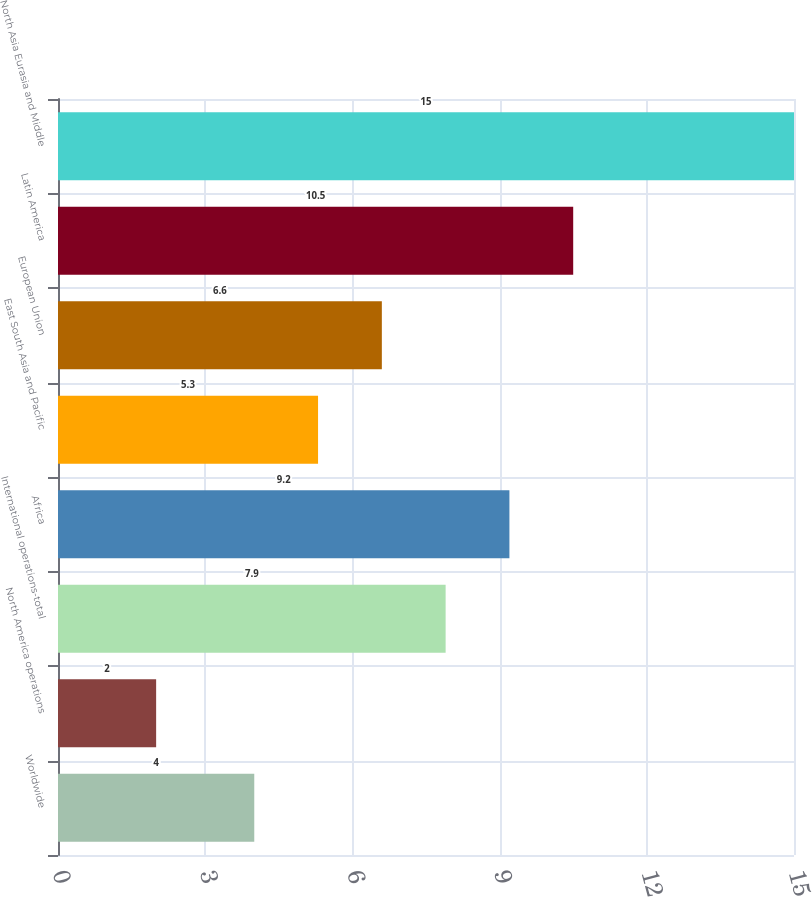Convert chart. <chart><loc_0><loc_0><loc_500><loc_500><bar_chart><fcel>Worldwide<fcel>North America operations<fcel>International operations-total<fcel>Africa<fcel>East South Asia and Pacific<fcel>European Union<fcel>Latin America<fcel>North Asia Eurasia and Middle<nl><fcel>4<fcel>2<fcel>7.9<fcel>9.2<fcel>5.3<fcel>6.6<fcel>10.5<fcel>15<nl></chart> 